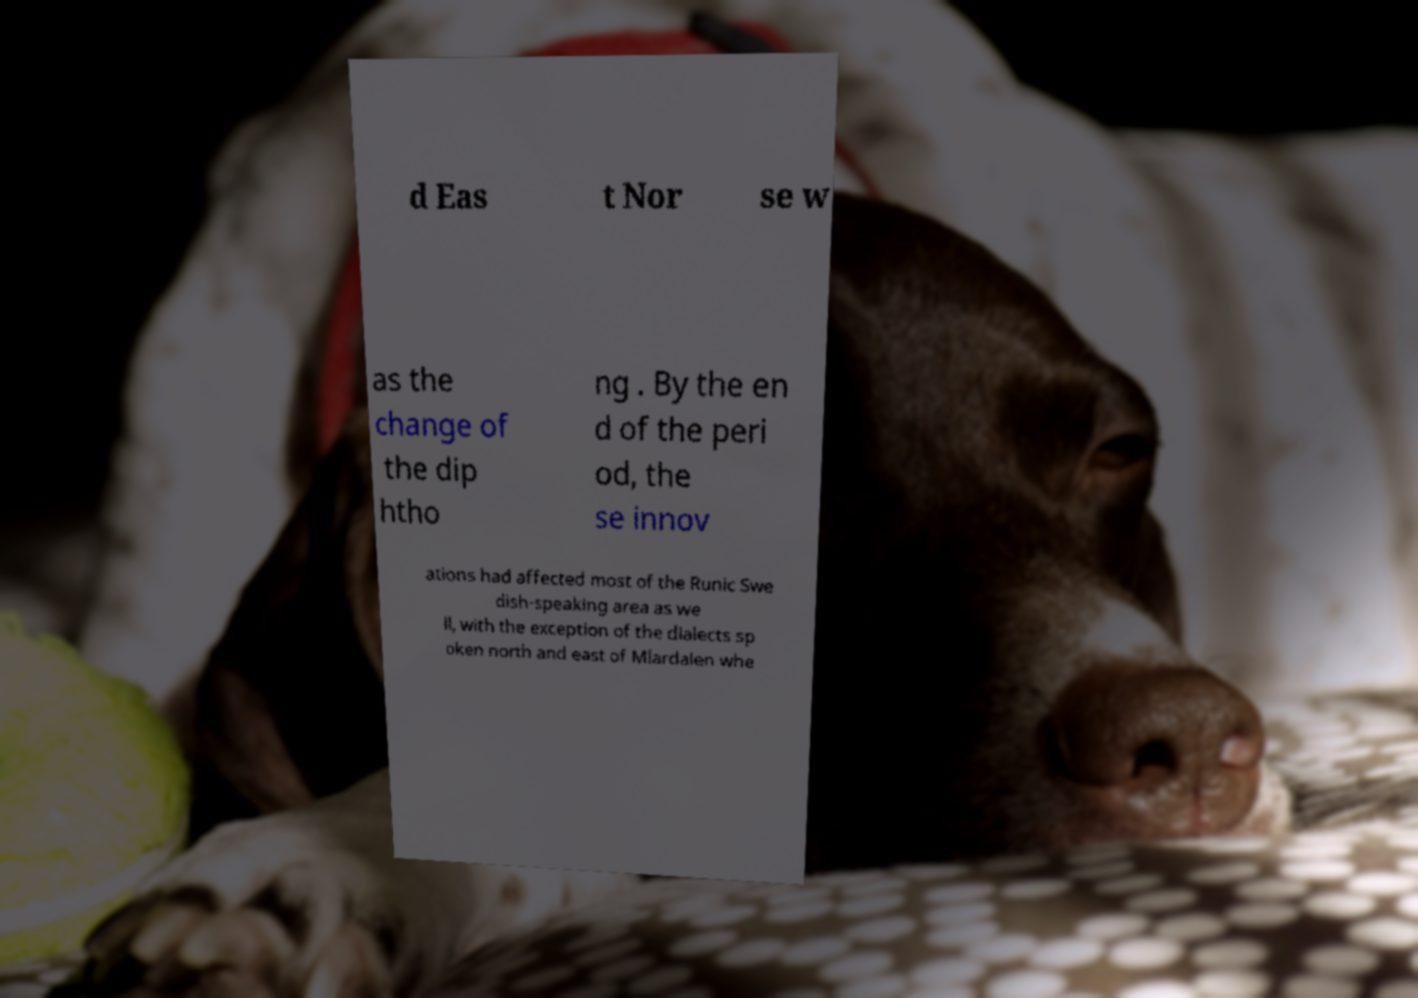For documentation purposes, I need the text within this image transcribed. Could you provide that? d Eas t Nor se w as the change of the dip htho ng . By the en d of the peri od, the se innov ations had affected most of the Runic Swe dish-speaking area as we ll, with the exception of the dialects sp oken north and east of Mlardalen whe 